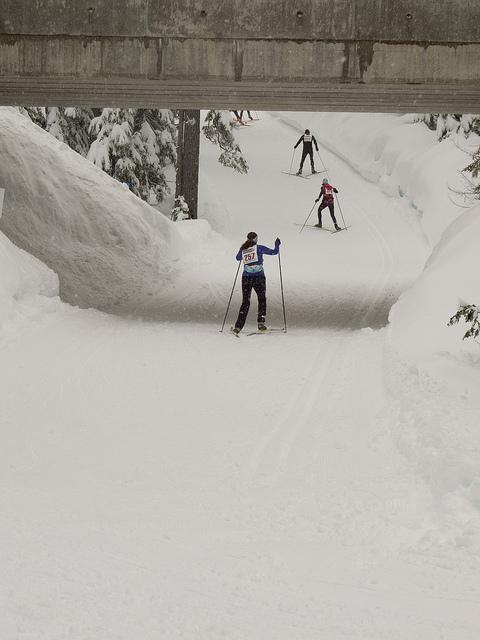How many people are visible?
Give a very brief answer. 3. How many people are skiing?
Give a very brief answer. 3. How many people can you see?
Give a very brief answer. 1. 